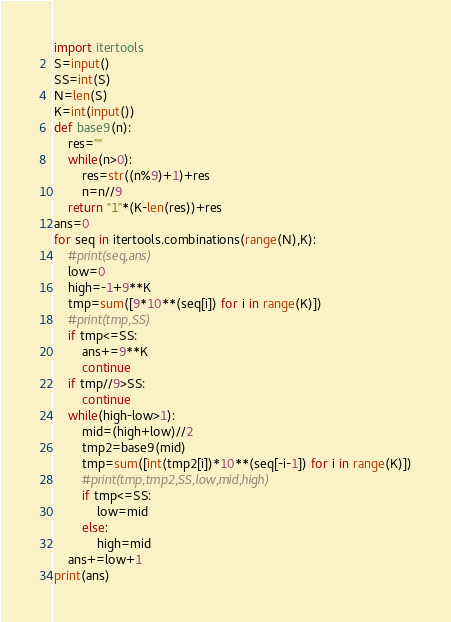<code> <loc_0><loc_0><loc_500><loc_500><_Python_>import itertools
S=input()
SS=int(S)
N=len(S)
K=int(input())
def base9(n):
    res=""
    while(n>0):
        res=str((n%9)+1)+res
        n=n//9
    return "1"*(K-len(res))+res
ans=0
for seq in itertools.combinations(range(N),K):
    #print(seq,ans)
    low=0
    high=-1+9**K
    tmp=sum([9*10**(seq[i]) for i in range(K)])
    #print(tmp,SS)
    if tmp<=SS:
        ans+=9**K
        continue
    if tmp//9>SS:
        continue
    while(high-low>1):
        mid=(high+low)//2
        tmp2=base9(mid)
        tmp=sum([int(tmp2[i])*10**(seq[-i-1]) for i in range(K)])
        #print(tmp,tmp2,SS,low,mid,high)
        if tmp<=SS:
            low=mid
        else:
            high=mid
    ans+=low+1
print(ans)
</code> 